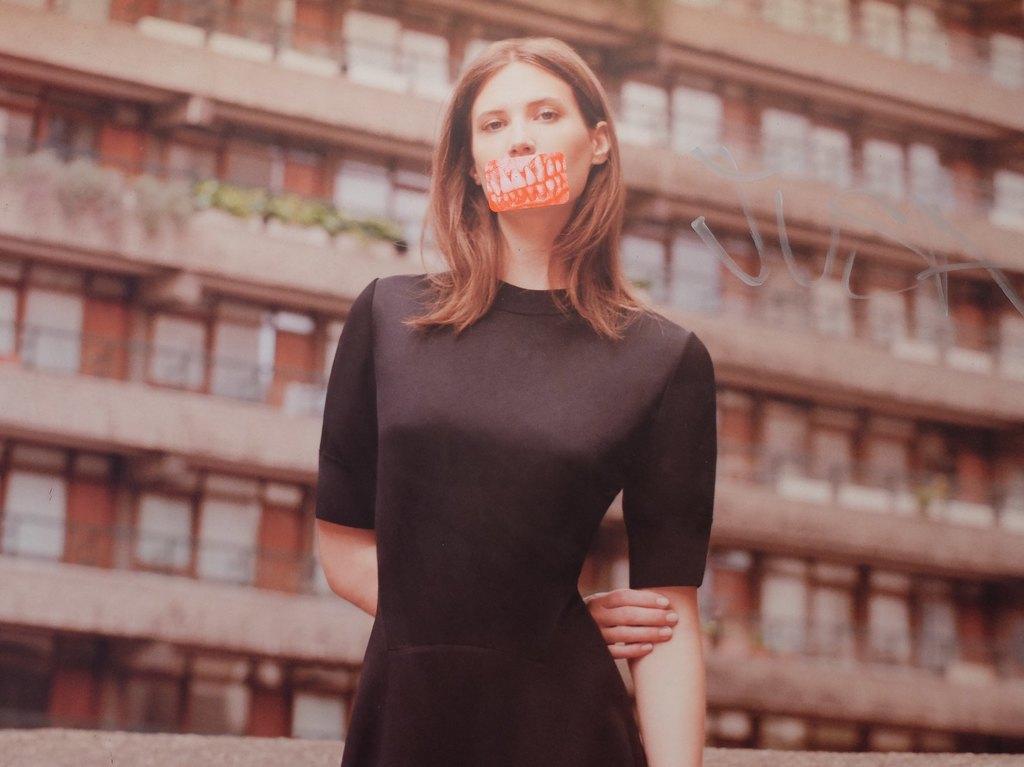Please provide a concise description of this image. This image consists of a woman wearing black dress. And there is a sticker on her mouth. In the background, there is a building. 